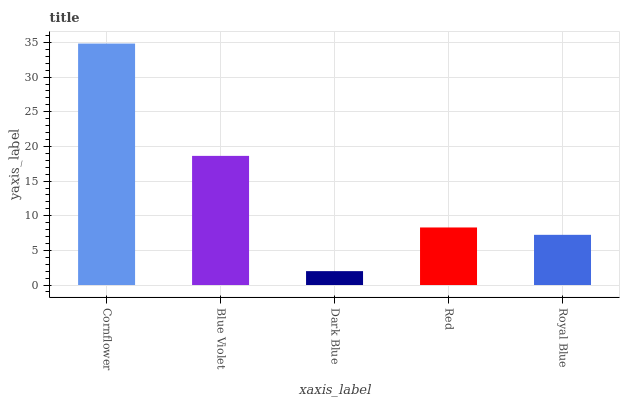Is Dark Blue the minimum?
Answer yes or no. Yes. Is Cornflower the maximum?
Answer yes or no. Yes. Is Blue Violet the minimum?
Answer yes or no. No. Is Blue Violet the maximum?
Answer yes or no. No. Is Cornflower greater than Blue Violet?
Answer yes or no. Yes. Is Blue Violet less than Cornflower?
Answer yes or no. Yes. Is Blue Violet greater than Cornflower?
Answer yes or no. No. Is Cornflower less than Blue Violet?
Answer yes or no. No. Is Red the high median?
Answer yes or no. Yes. Is Red the low median?
Answer yes or no. Yes. Is Dark Blue the high median?
Answer yes or no. No. Is Blue Violet the low median?
Answer yes or no. No. 